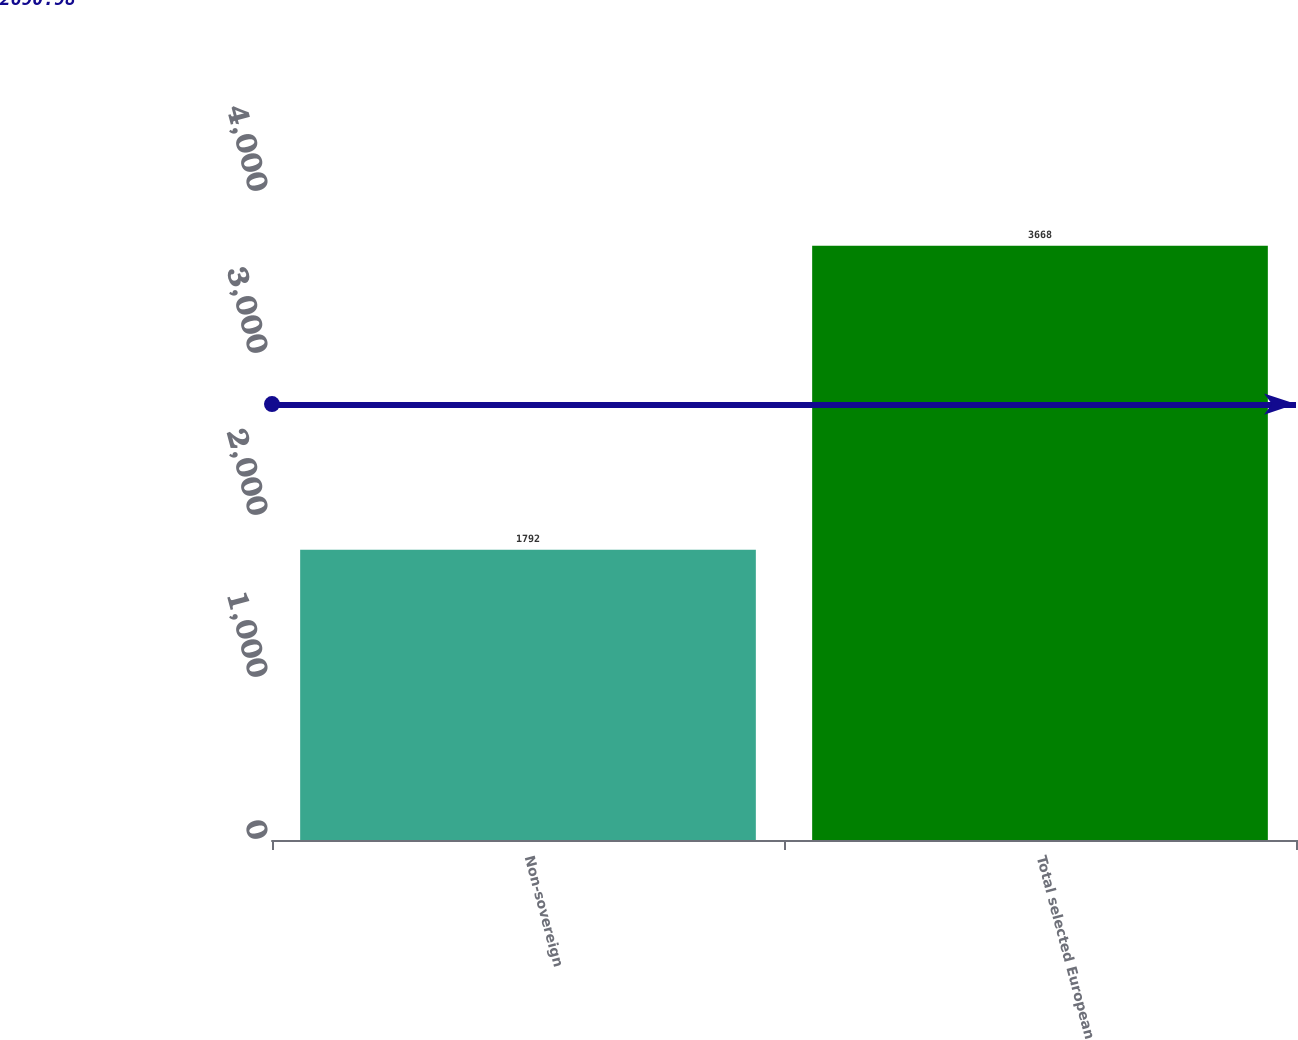Convert chart to OTSL. <chart><loc_0><loc_0><loc_500><loc_500><bar_chart><fcel>Non-sovereign<fcel>Total selected European<nl><fcel>1792<fcel>3668<nl></chart> 